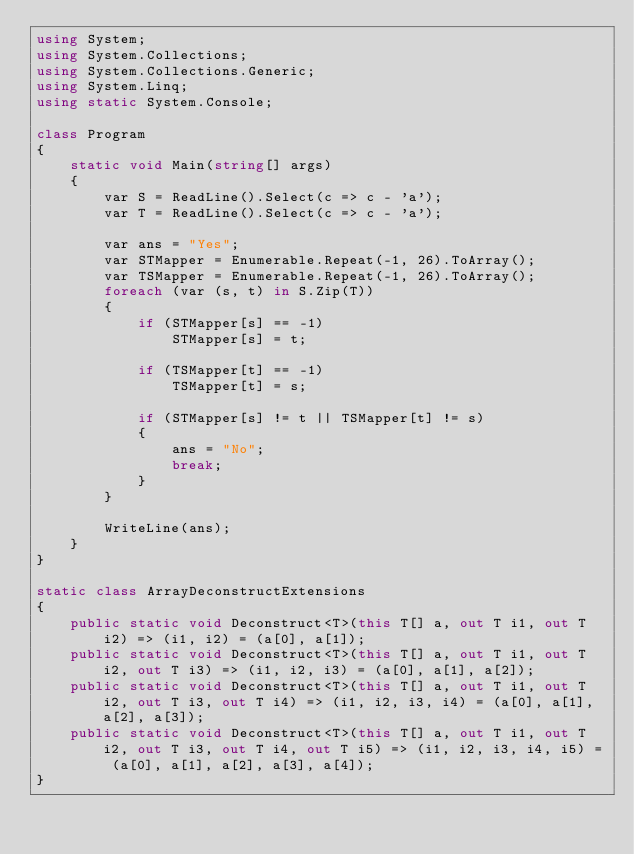<code> <loc_0><loc_0><loc_500><loc_500><_C#_>using System;
using System.Collections;
using System.Collections.Generic;
using System.Linq;
using static System.Console;

class Program
{
    static void Main(string[] args)
    {
        var S = ReadLine().Select(c => c - 'a');
        var T = ReadLine().Select(c => c - 'a');

        var ans = "Yes";
        var STMapper = Enumerable.Repeat(-1, 26).ToArray();
        var TSMapper = Enumerable.Repeat(-1, 26).ToArray();
        foreach (var (s, t) in S.Zip(T))
        {
            if (STMapper[s] == -1)
                STMapper[s] = t;

            if (TSMapper[t] == -1)
                TSMapper[t] = s;

            if (STMapper[s] != t || TSMapper[t] != s)
            {
                ans = "No";
                break;
            }
        }

        WriteLine(ans);
    }
}

static class ArrayDeconstructExtensions
{
    public static void Deconstruct<T>(this T[] a, out T i1, out T i2) => (i1, i2) = (a[0], a[1]);
    public static void Deconstruct<T>(this T[] a, out T i1, out T i2, out T i3) => (i1, i2, i3) = (a[0], a[1], a[2]);
    public static void Deconstruct<T>(this T[] a, out T i1, out T i2, out T i3, out T i4) => (i1, i2, i3, i4) = (a[0], a[1], a[2], a[3]);
    public static void Deconstruct<T>(this T[] a, out T i1, out T i2, out T i3, out T i4, out T i5) => (i1, i2, i3, i4, i5) = (a[0], a[1], a[2], a[3], a[4]);
}
</code> 